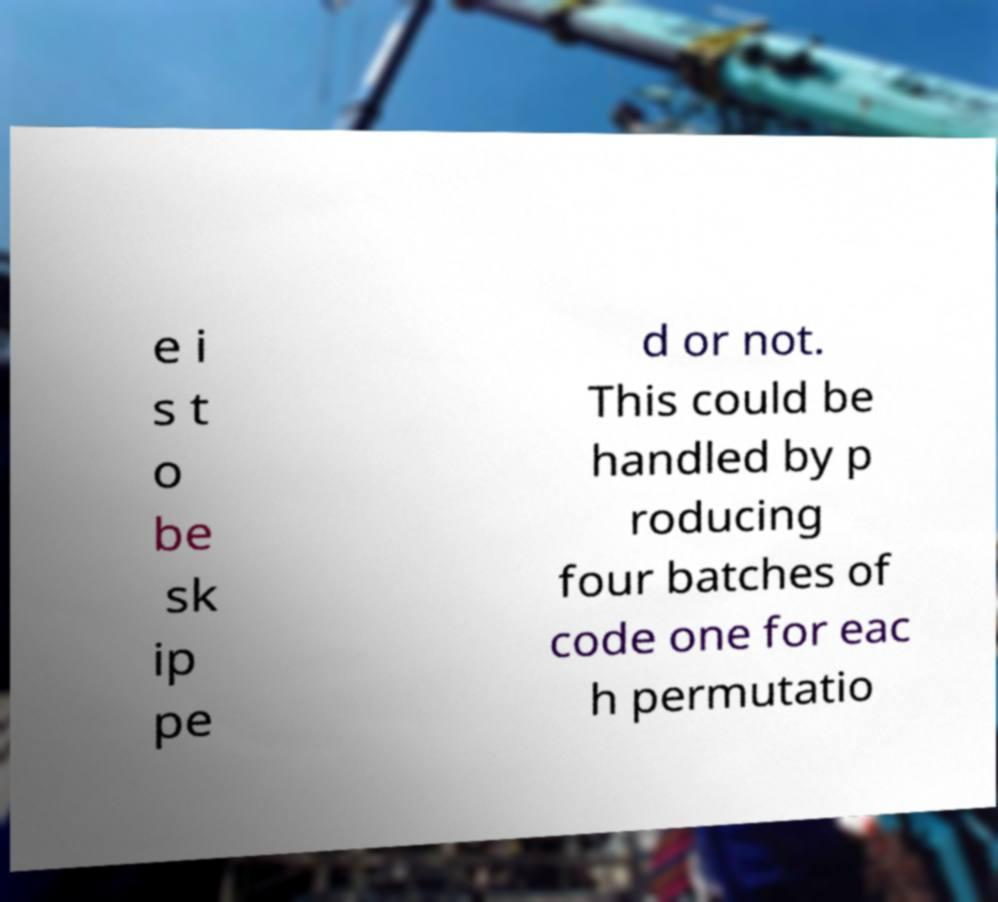What messages or text are displayed in this image? I need them in a readable, typed format. e i s t o be sk ip pe d or not. This could be handled by p roducing four batches of code one for eac h permutatio 